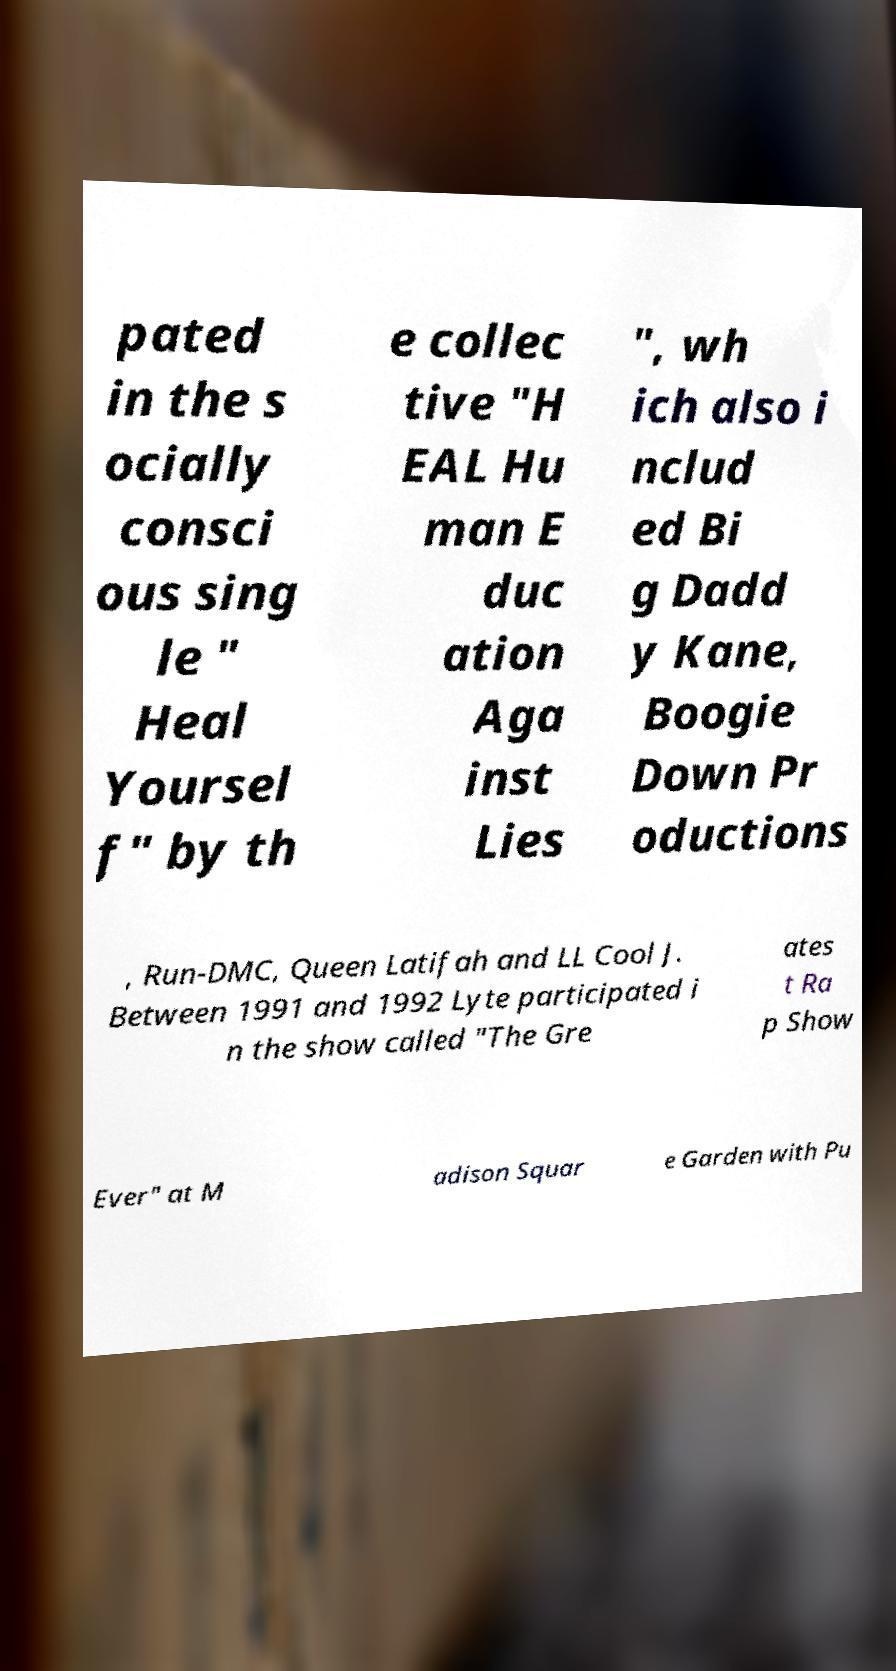What messages or text are displayed in this image? I need them in a readable, typed format. pated in the s ocially consci ous sing le " Heal Yoursel f" by th e collec tive "H EAL Hu man E duc ation Aga inst Lies ", wh ich also i nclud ed Bi g Dadd y Kane, Boogie Down Pr oductions , Run-DMC, Queen Latifah and LL Cool J. Between 1991 and 1992 Lyte participated i n the show called "The Gre ates t Ra p Show Ever" at M adison Squar e Garden with Pu 